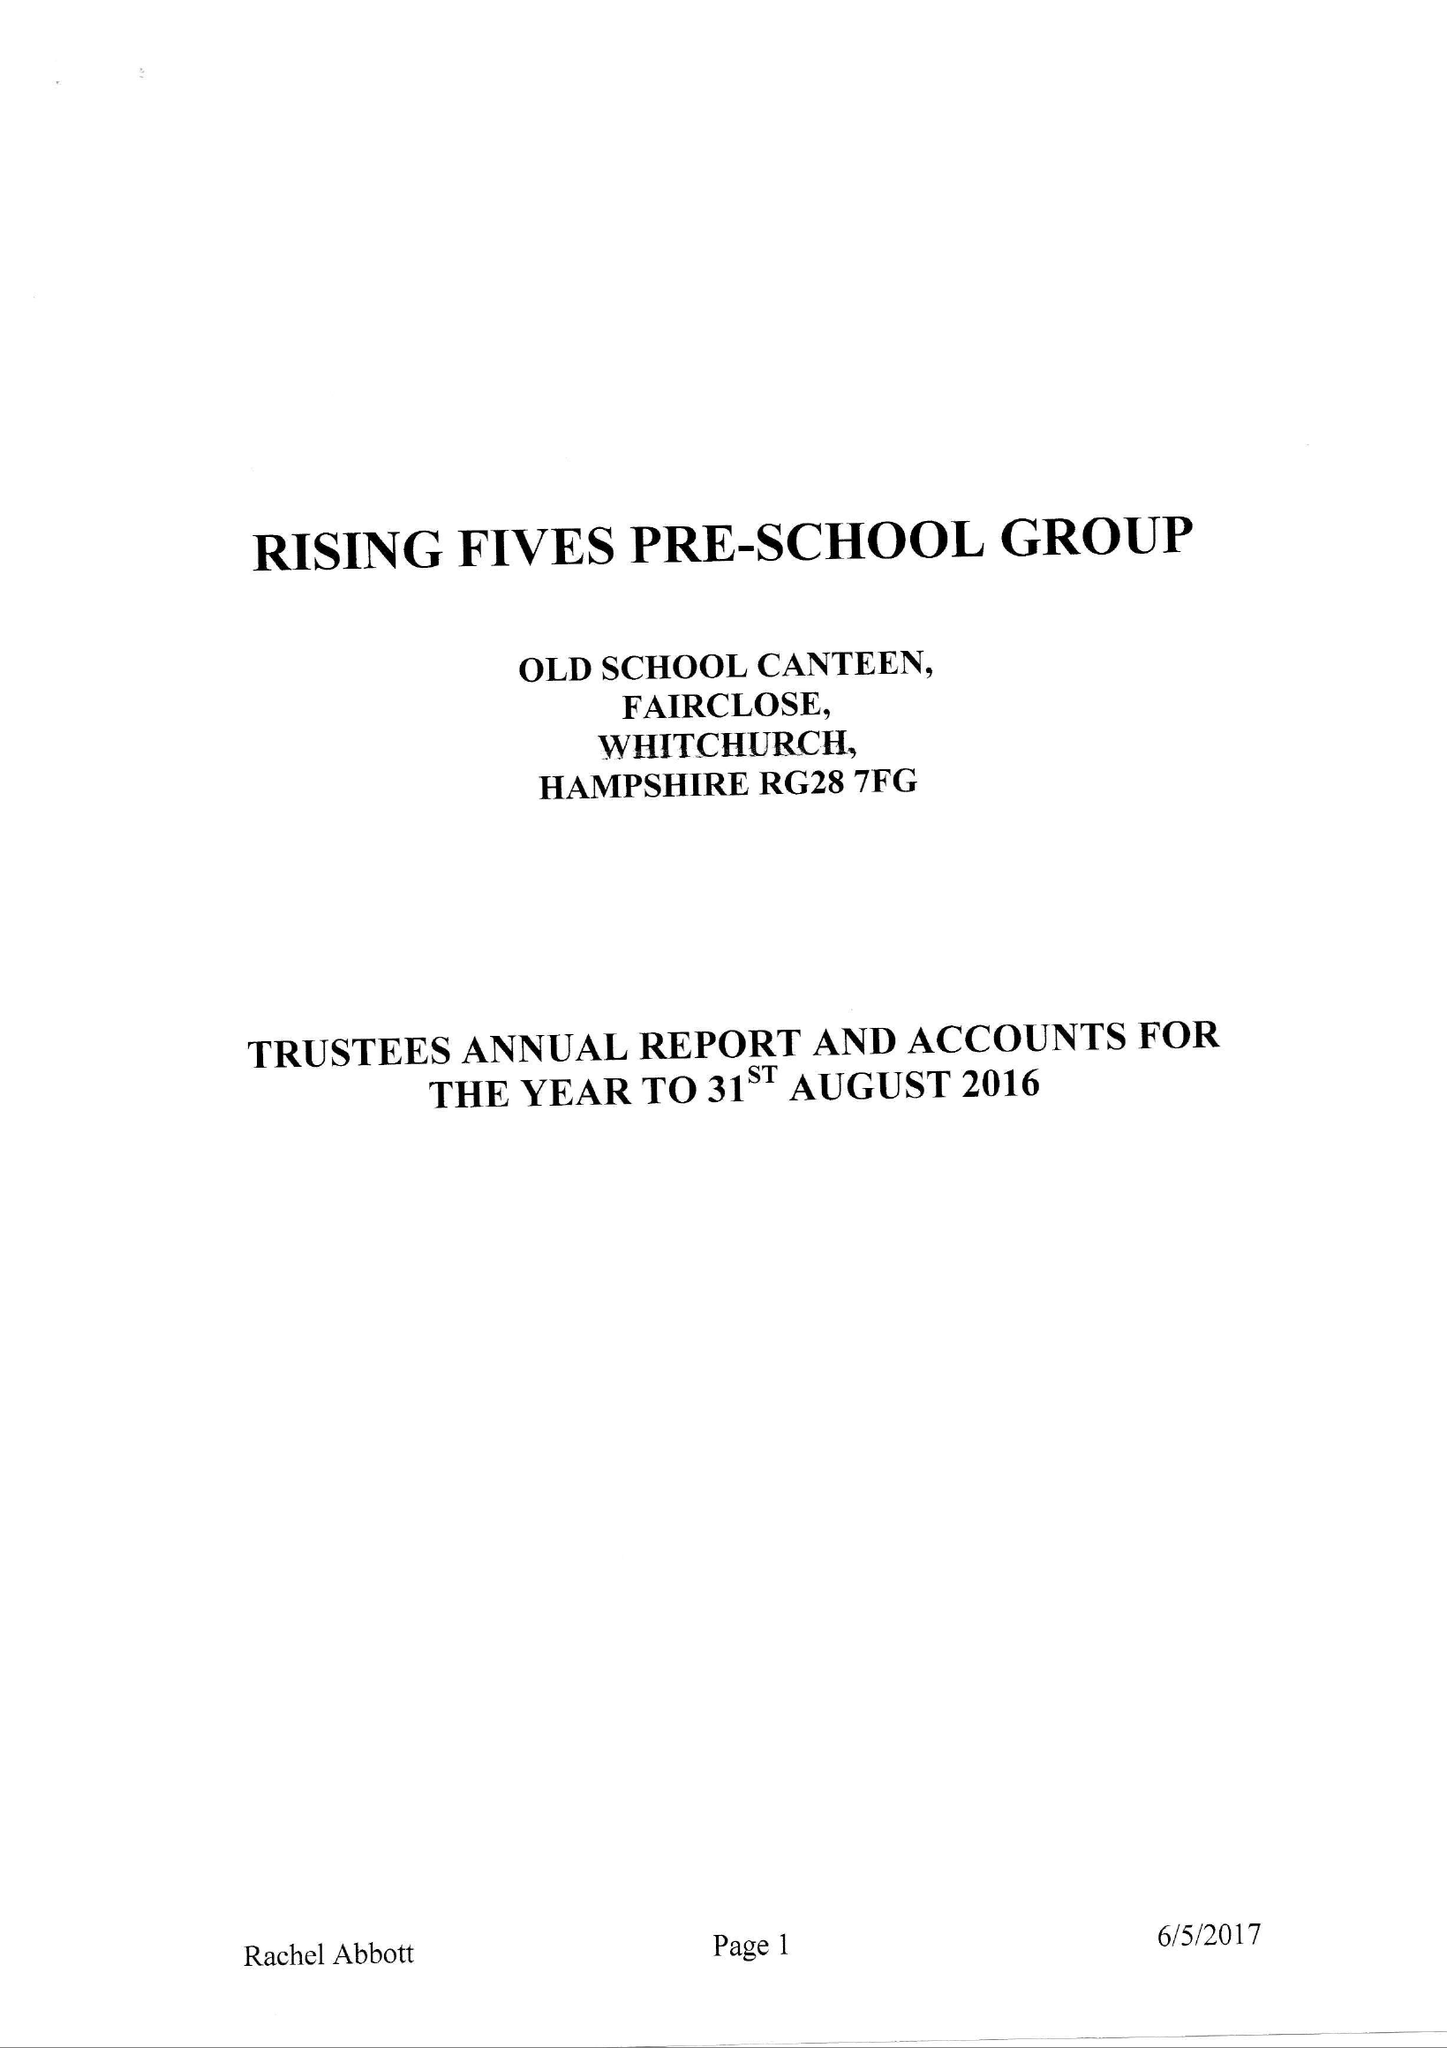What is the value for the charity_number?
Answer the question using a single word or phrase. 270065 